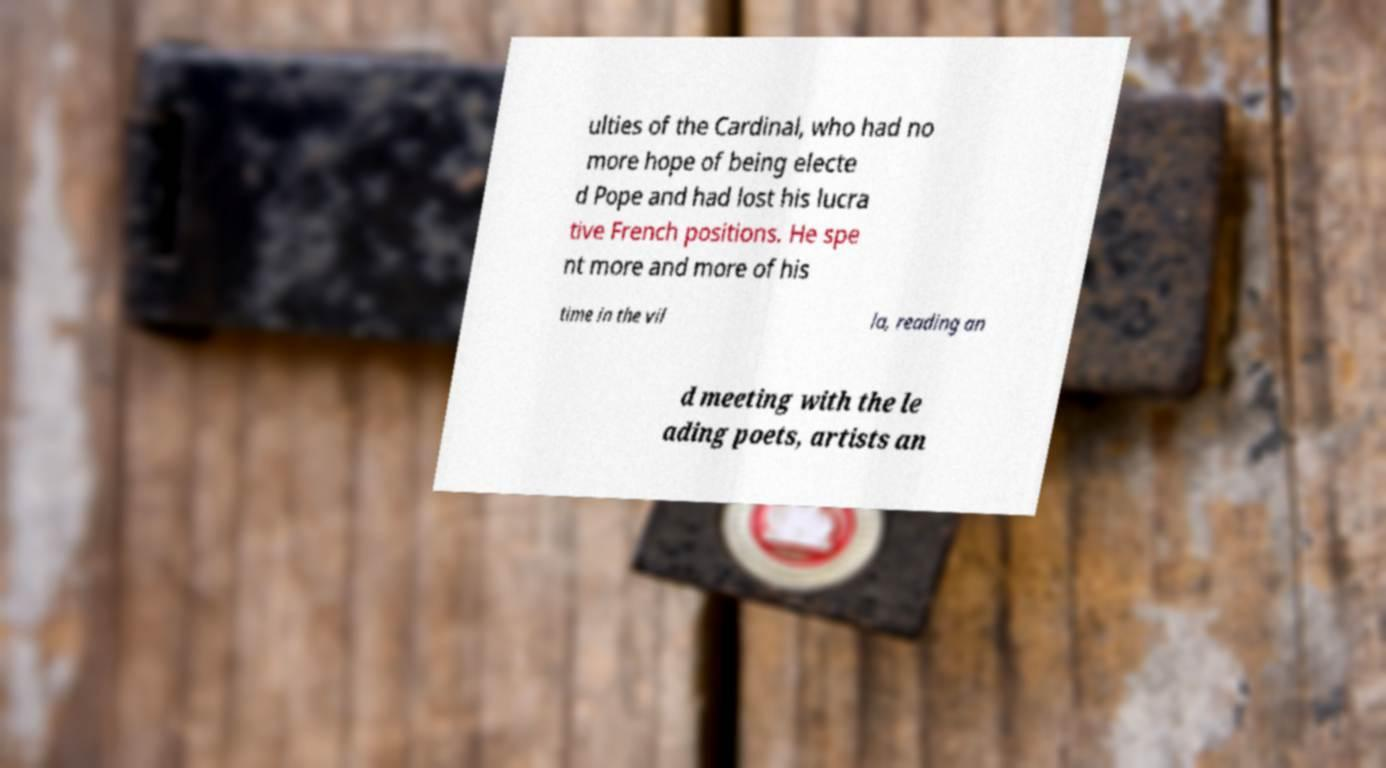Please read and relay the text visible in this image. What does it say? ulties of the Cardinal, who had no more hope of being electe d Pope and had lost his lucra tive French positions. He spe nt more and more of his time in the vil la, reading an d meeting with the le ading poets, artists an 